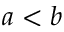Convert formula to latex. <formula><loc_0><loc_0><loc_500><loc_500>a < b</formula> 